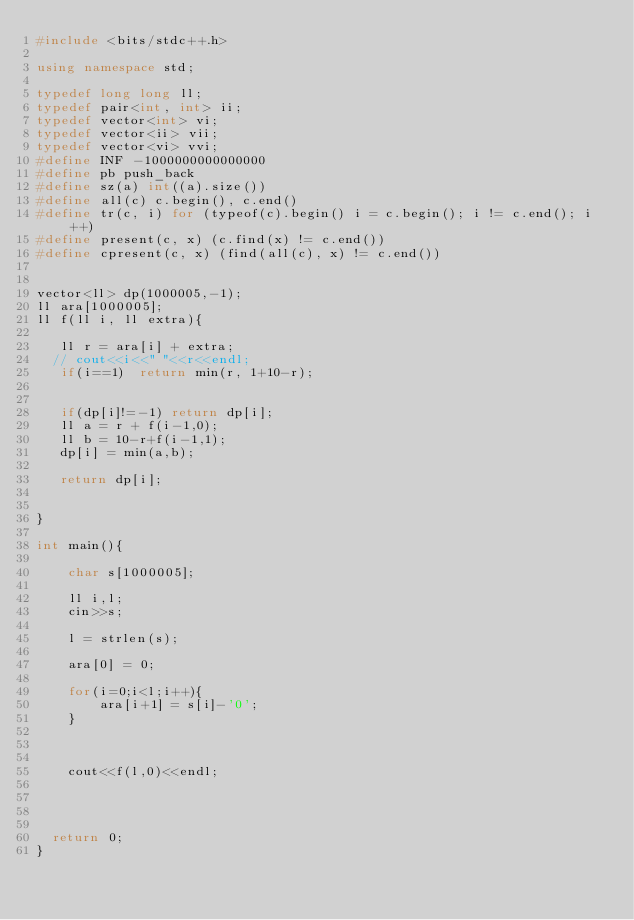<code> <loc_0><loc_0><loc_500><loc_500><_C++_>#include <bits/stdc++.h>

using namespace std;

typedef long long ll;
typedef pair<int, int> ii;
typedef vector<int> vi;
typedef vector<ii> vii;
typedef vector<vi> vvi;
#define INF -1000000000000000
#define pb push_back
#define sz(a) int((a).size())
#define all(c) c.begin(), c.end()
#define tr(c, i) for (typeof(c).begin() i = c.begin(); i != c.end(); i++)
#define present(c, x) (c.find(x) != c.end())
#define cpresent(c, x) (find(all(c), x) != c.end())


vector<ll> dp(1000005,-1);
ll ara[1000005];
ll f(ll i, ll extra){
    
   ll r = ara[i] + extra;
  // cout<<i<<" "<<r<<endl;
   if(i==1)  return min(r, 1+10-r);
    
   
   if(dp[i]!=-1) return dp[i];
   ll a = r + f(i-1,0);
   ll b = 10-r+f(i-1,1);
   dp[i] = min(a,b);
   
   return dp[i]; 


}

int main(){
	
    char s[1000005];

    ll i,l;
    cin>>s;

    l = strlen(s);

    ara[0] = 0;

    for(i=0;i<l;i++){
        ara[i+1] = s[i]-'0';
    }

    

    cout<<f(l,0)<<endl;




	return 0;
}</code> 